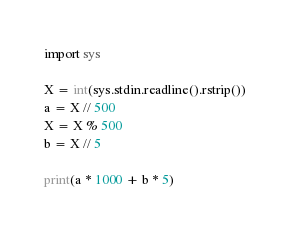<code> <loc_0><loc_0><loc_500><loc_500><_Python_>import sys

X = int(sys.stdin.readline().rstrip())
a = X // 500
X = X % 500
b = X // 5

print(a * 1000 + b * 5)
</code> 